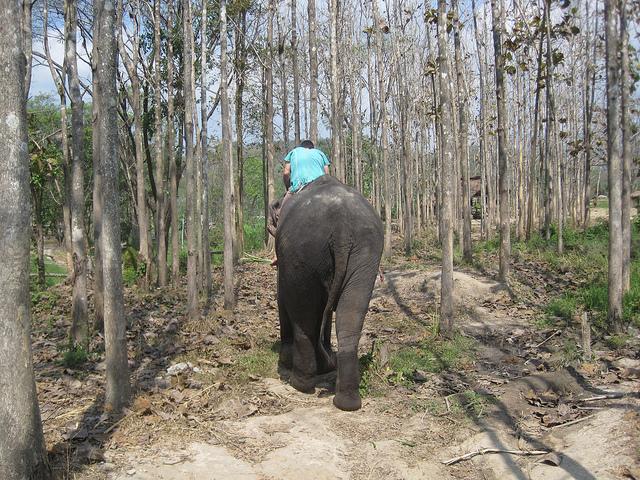What color is the t-shirt?
Short answer required. Blue. Is the elephant bigger than the person?
Concise answer only. Yes. Is this a park?
Short answer required. No. What color is the elephant?
Be succinct. Gray. What animal is this?
Answer briefly. Elephant. 